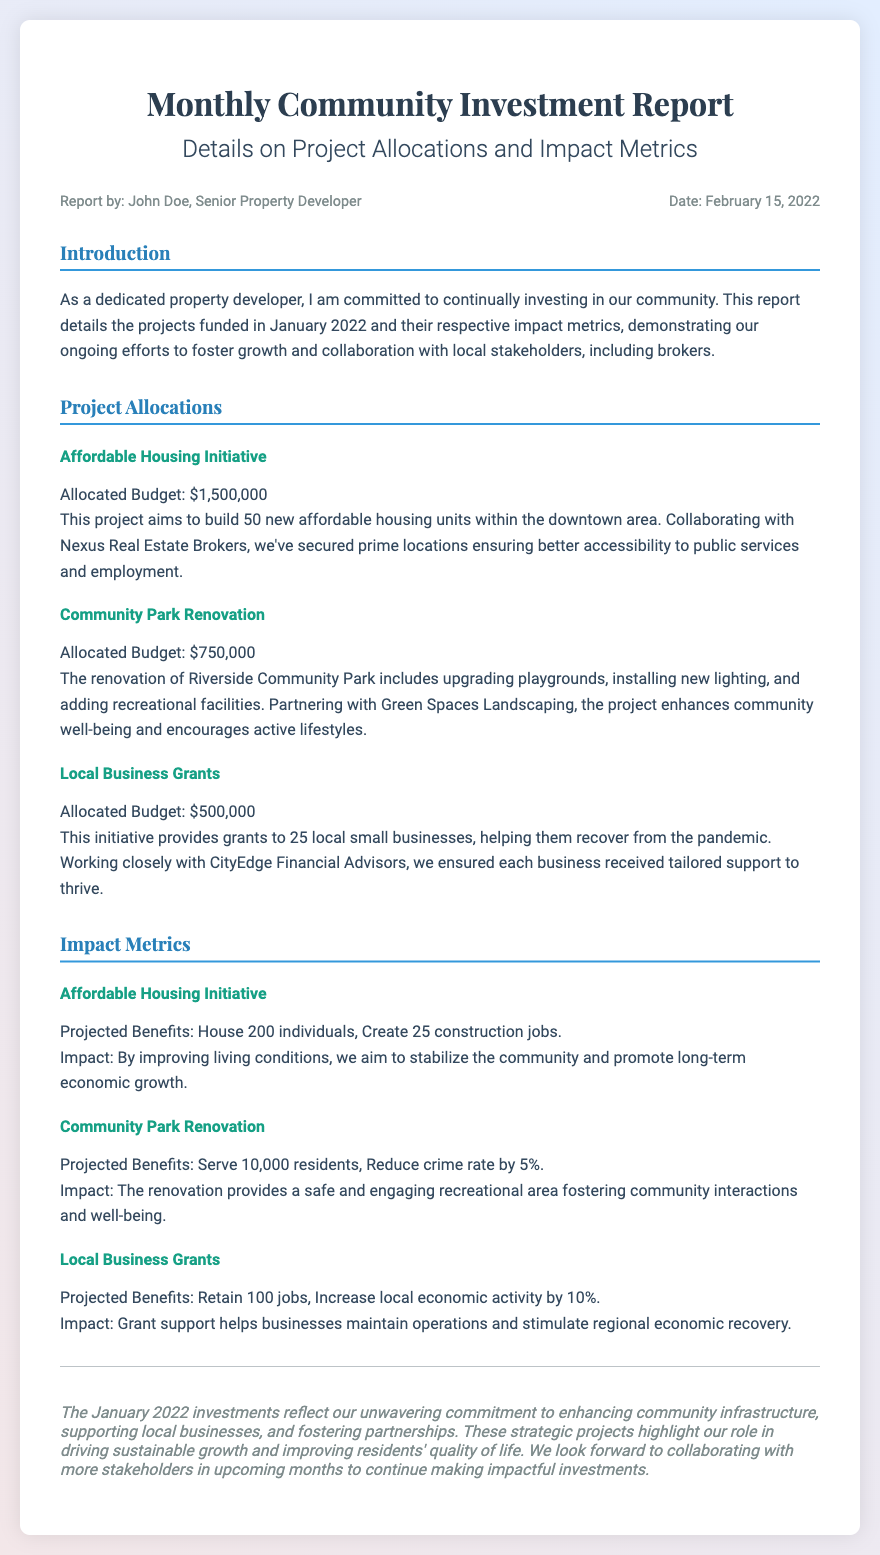What is the total allocated budget for the Affordable Housing Initiative? The allocated budget for the Affordable Housing Initiative is specified as $1,500,000 in the document.
Answer: $1,500,000 What are the projected benefits of the Community Park Renovation? The projected benefits for the Community Park Renovation are provided as serving 10,000 residents and reducing the crime rate by 5%.
Answer: Serve 10,000 residents, Reduce crime rate by 5% Who is the report authored by? The document states that the report is authored by John Doe, Senior Property Developer.
Answer: John Doe, Senior Property Developer What is the name of the financial advisor involved in the Local Business Grants initiative? The document names CityEdge Financial Advisors as the partner for the Local Business Grants initiative.
Answer: CityEdge Financial Advisors How many new affordable housing units are planned in the Affordable Housing Initiative? The document indicates that the Affordable Housing Initiative aims to build 50 new affordable housing units.
Answer: 50 new affordable housing units What is the total allocated budget for the Local Business Grants? The allocated budget mentioned for the Local Business Grants is $500,000.
Answer: $500,000 What is the overall aim of the Community Park Renovation project according to the document? The document describes that the aim of the Community Park Renovation project is to enhance community well-being and encourage active lifestyles.
Answer: Enhance community well-being and encourage active lifestyles What is the date the report was published? The document indicates that the report was published on February 15, 2022.
Answer: February 15, 2022 What is the impact of the Affordable Housing Initiative on the community? The document states that the impact includes stabilizing the community and promoting long-term economic growth.
Answer: Stabilize the community and promote long-term economic growth 